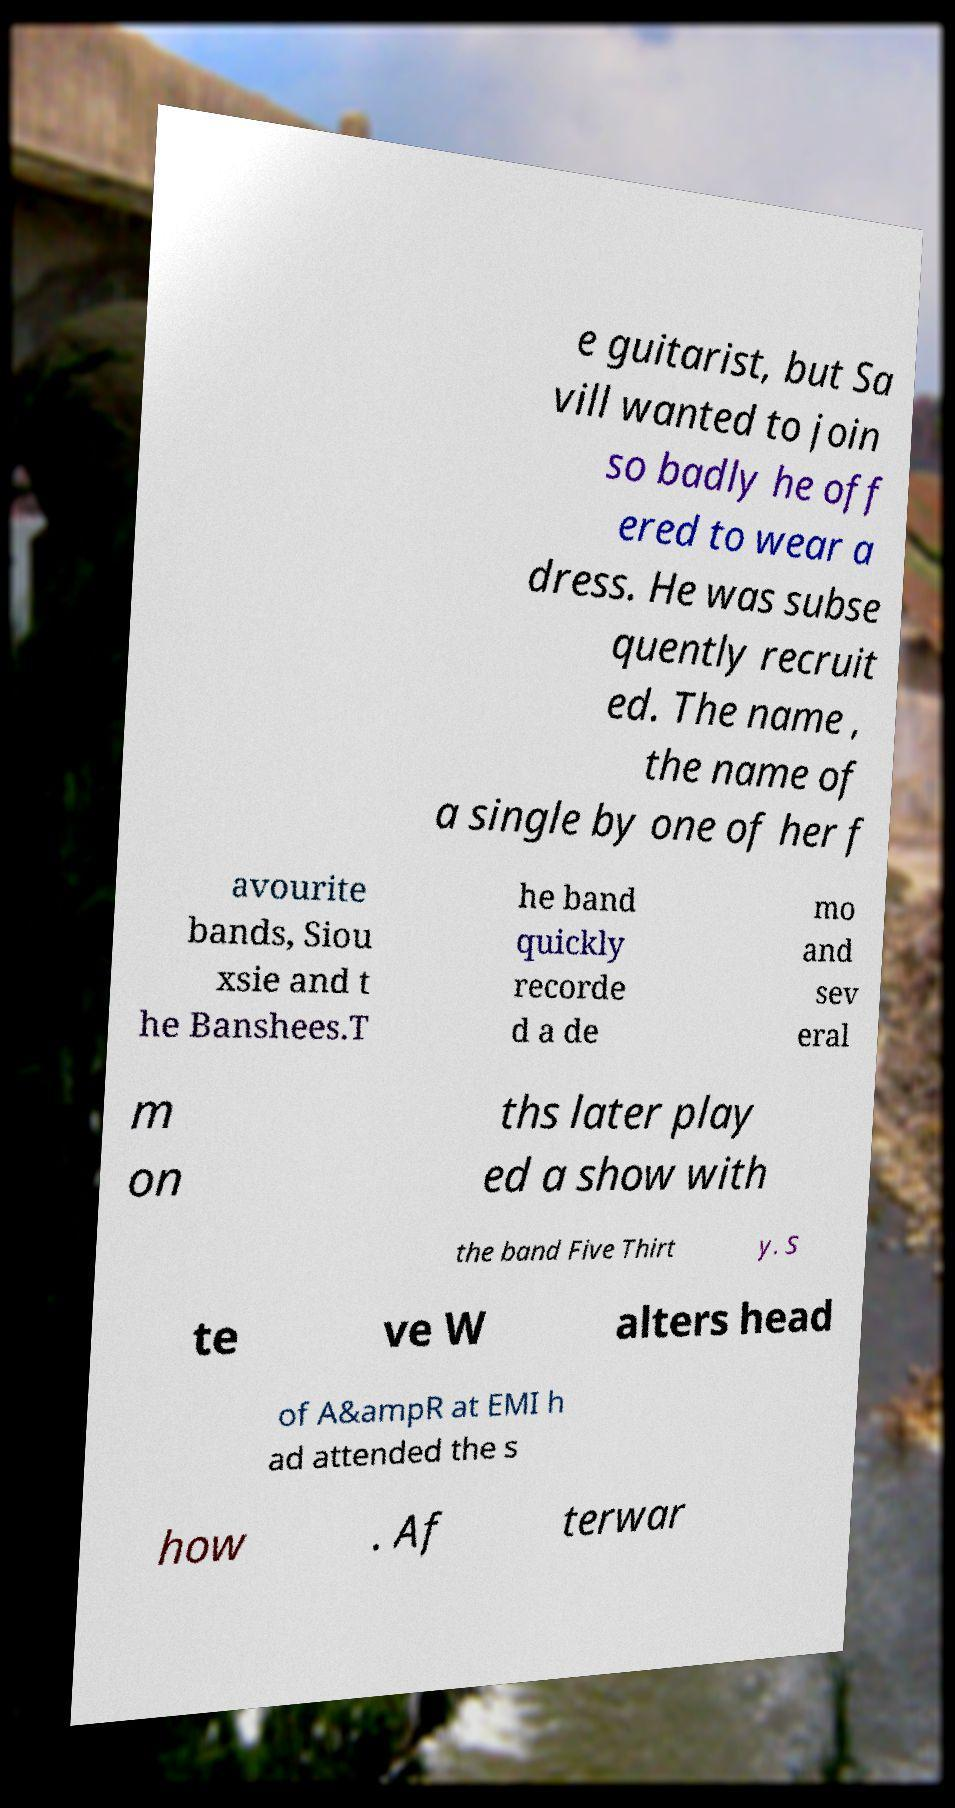Please read and relay the text visible in this image. What does it say? e guitarist, but Sa vill wanted to join so badly he off ered to wear a dress. He was subse quently recruit ed. The name , the name of a single by one of her f avourite bands, Siou xsie and t he Banshees.T he band quickly recorde d a de mo and sev eral m on ths later play ed a show with the band Five Thirt y. S te ve W alters head of A&ampR at EMI h ad attended the s how . Af terwar 